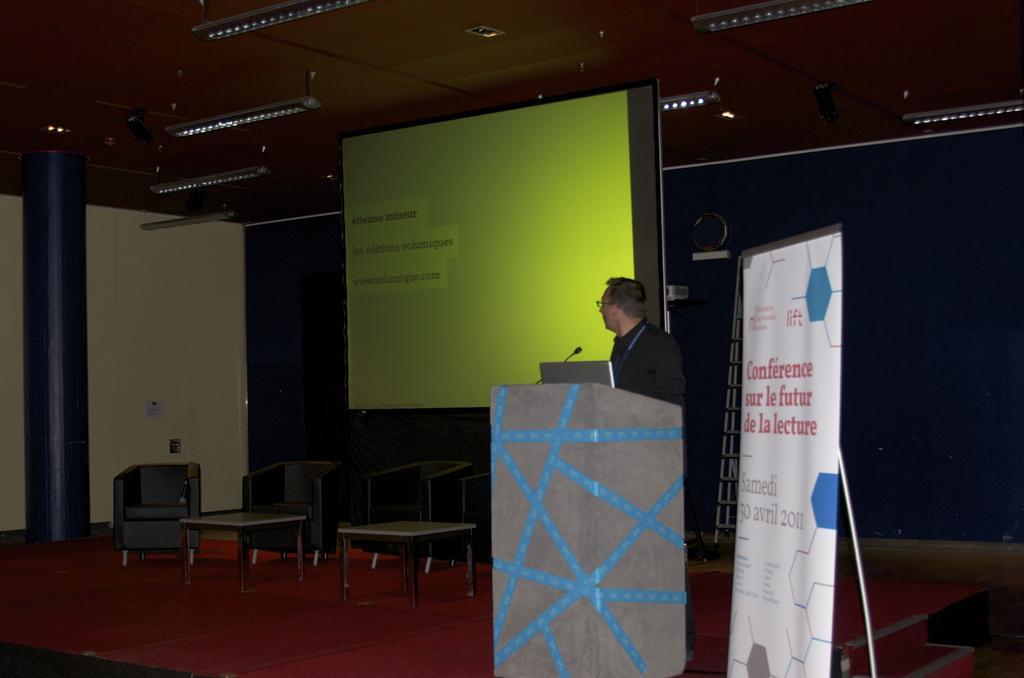How would you summarize this image in a sentence or two? In this image I can see a chair,table and man is standing in front of the podium. There is a mic and a laptop. At the back side there is a screen. 